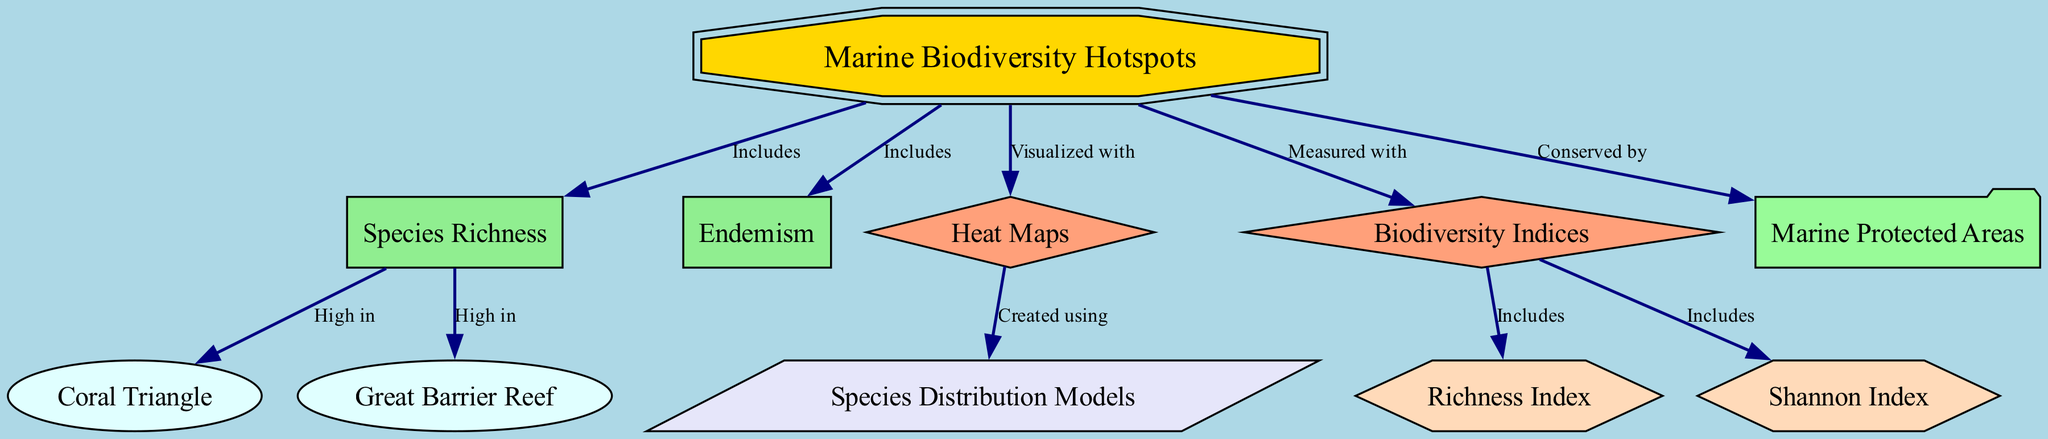What are the two main components included in marine biodiversity hotspots? The diagram indicates that marine biodiversity hotspots include species richness and endemism as fundamental components.
Answer: Species Richness, Endemism Which marine area is high in species richness? The diagram shows that both the Coral Triangle and Great Barrier Reef are high in species richness.
Answer: Coral Triangle, Great Barrier Reef What type of visualization is used to represent marine biodiversity hotspots? According to the diagram, marine biodiversity hotspots are visualized with heat maps.
Answer: Heat Maps How many biodiversity indices are included in the diagram? The diagram lists two biodiversity indices: Richness Index and Shannon Index, indicating that there are two indices present.
Answer: Two What does species distribution models create? The diagram shows that species distribution models are created using heat maps, indicating the relationship between these two elements.
Answer: Heat Maps How are marine biodiversity hotspots conserved? The diagram indicates that marine biodiversity hotspots are conserved by marine protected areas, which directly connects these two concepts.
Answer: Marine Protected Areas What shape represents biodiversity indices in the diagram? The diagram uses a diamond shape to represent biodiversity indices, showcasing how this node is visually distinguished.
Answer: Diamond What color is used for marine biodiversity hotspots in the diagram? The diagram visually represents marine biodiversity hotspots using a gold color fill, indicating its distinct importance.
Answer: Gold Which biodiversity index is specifically included in the diagram? The diagram highlights two specific biodiversity indices: richness index and Shannon index, showing their significance in measuring biodiversity.
Answer: Richness Index, Shannon Index 